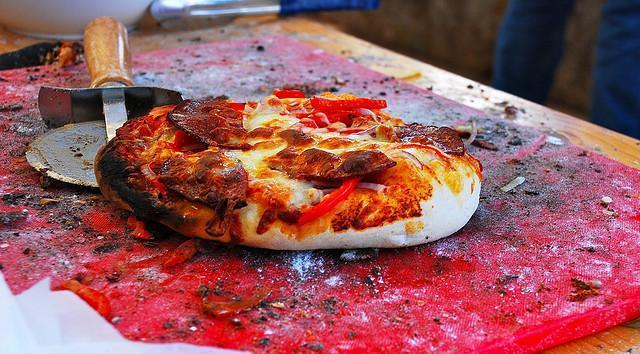How many people are visible?
Give a very brief answer. 1. How many birds are in the air?
Give a very brief answer. 0. 